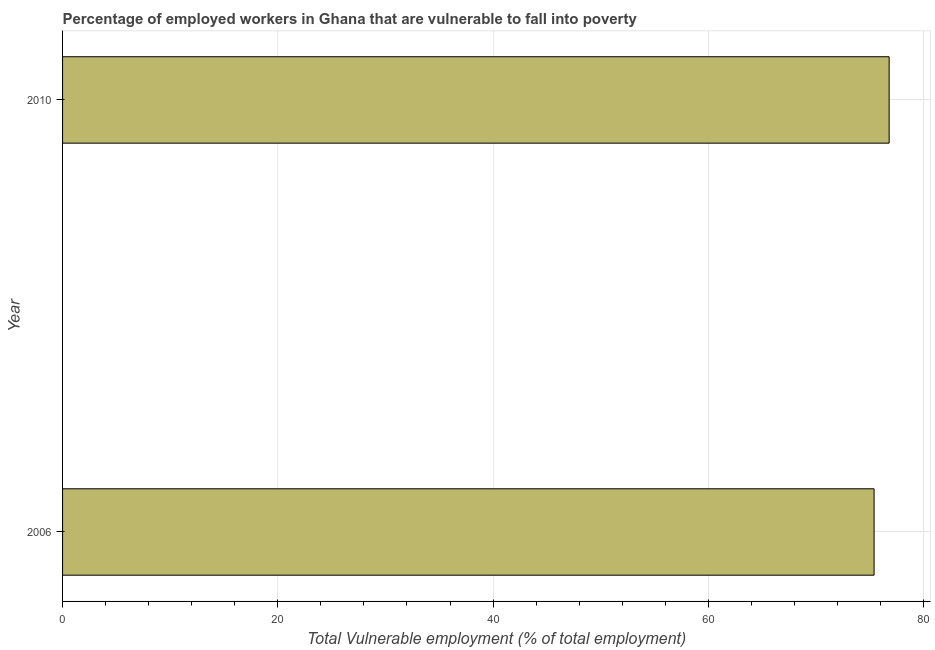Does the graph contain grids?
Offer a very short reply. Yes. What is the title of the graph?
Ensure brevity in your answer.  Percentage of employed workers in Ghana that are vulnerable to fall into poverty. What is the label or title of the X-axis?
Ensure brevity in your answer.  Total Vulnerable employment (% of total employment). What is the label or title of the Y-axis?
Make the answer very short. Year. What is the total vulnerable employment in 2010?
Ensure brevity in your answer.  76.8. Across all years, what is the maximum total vulnerable employment?
Your answer should be very brief. 76.8. Across all years, what is the minimum total vulnerable employment?
Provide a short and direct response. 75.4. In which year was the total vulnerable employment maximum?
Your answer should be compact. 2010. In which year was the total vulnerable employment minimum?
Provide a short and direct response. 2006. What is the sum of the total vulnerable employment?
Offer a terse response. 152.2. What is the average total vulnerable employment per year?
Provide a succinct answer. 76.1. What is the median total vulnerable employment?
Give a very brief answer. 76.1. Do a majority of the years between 2006 and 2010 (inclusive) have total vulnerable employment greater than 16 %?
Ensure brevity in your answer.  Yes. What is the ratio of the total vulnerable employment in 2006 to that in 2010?
Give a very brief answer. 0.98. In how many years, is the total vulnerable employment greater than the average total vulnerable employment taken over all years?
Offer a terse response. 1. How many years are there in the graph?
Make the answer very short. 2. Are the values on the major ticks of X-axis written in scientific E-notation?
Make the answer very short. No. What is the Total Vulnerable employment (% of total employment) in 2006?
Your answer should be very brief. 75.4. What is the Total Vulnerable employment (% of total employment) in 2010?
Provide a succinct answer. 76.8. What is the difference between the Total Vulnerable employment (% of total employment) in 2006 and 2010?
Keep it short and to the point. -1.4. What is the ratio of the Total Vulnerable employment (% of total employment) in 2006 to that in 2010?
Offer a terse response. 0.98. 